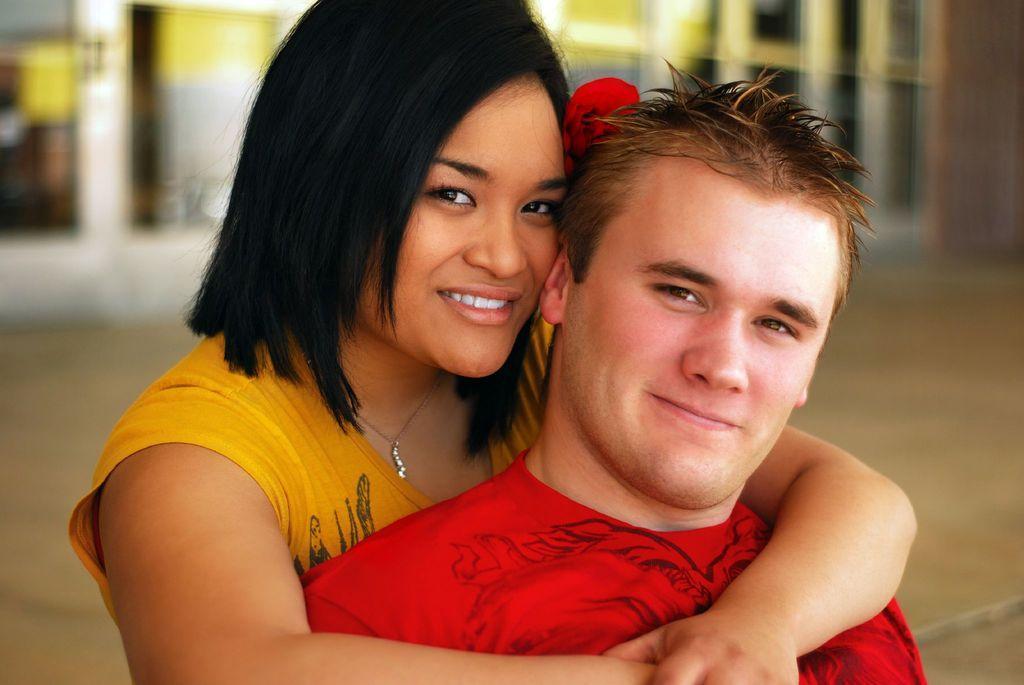Can you describe this image briefly? In this picture we can see a man, woman, they are smiling and in the background we can see the ground, building and it is blurry. 